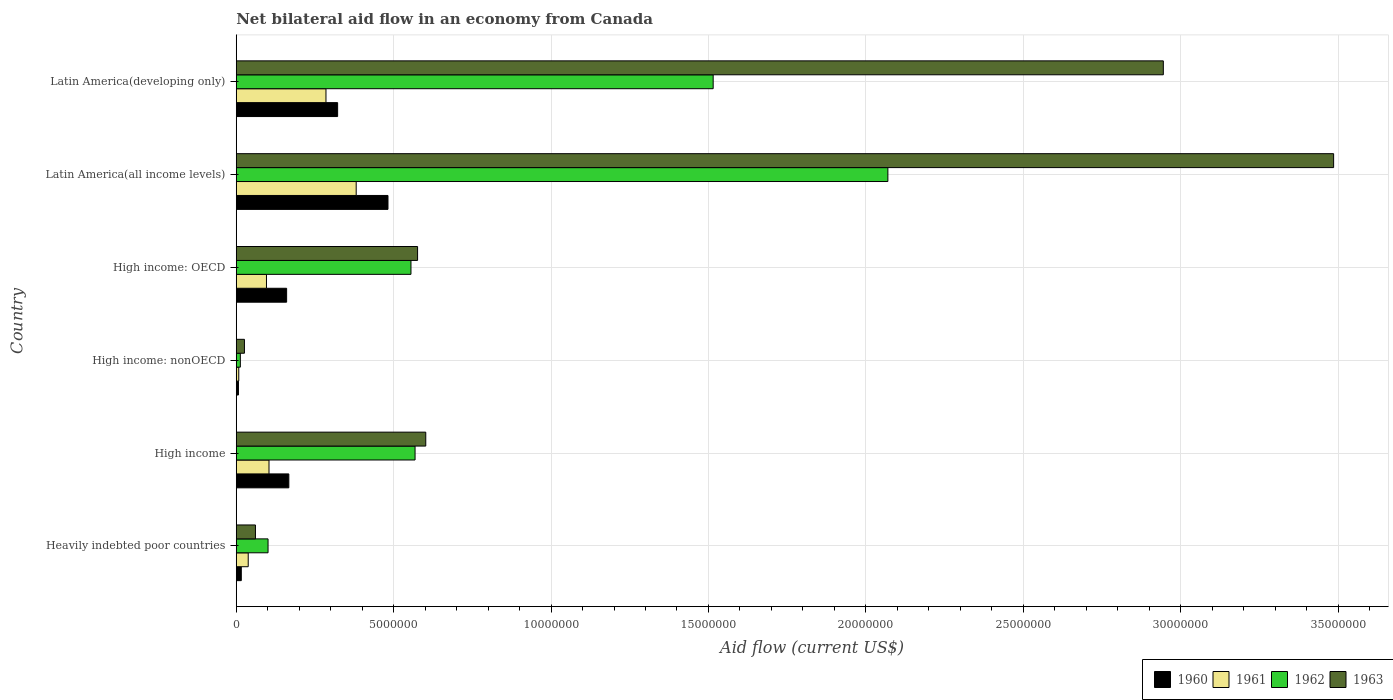How many different coloured bars are there?
Provide a short and direct response. 4. How many groups of bars are there?
Offer a very short reply. 6. Are the number of bars per tick equal to the number of legend labels?
Keep it short and to the point. Yes. How many bars are there on the 6th tick from the top?
Offer a terse response. 4. What is the label of the 4th group of bars from the top?
Provide a short and direct response. High income: nonOECD. Across all countries, what is the maximum net bilateral aid flow in 1961?
Provide a short and direct response. 3.81e+06. In which country was the net bilateral aid flow in 1960 maximum?
Make the answer very short. Latin America(all income levels). In which country was the net bilateral aid flow in 1960 minimum?
Keep it short and to the point. High income: nonOECD. What is the total net bilateral aid flow in 1960 in the graph?
Provide a short and direct response. 1.15e+07. What is the difference between the net bilateral aid flow in 1961 in High income: nonOECD and that in Latin America(all income levels)?
Provide a short and direct response. -3.73e+06. What is the difference between the net bilateral aid flow in 1960 in Latin America(all income levels) and the net bilateral aid flow in 1963 in Latin America(developing only)?
Give a very brief answer. -2.46e+07. What is the average net bilateral aid flow in 1963 per country?
Your response must be concise. 1.28e+07. What is the difference between the net bilateral aid flow in 1961 and net bilateral aid flow in 1962 in Heavily indebted poor countries?
Make the answer very short. -6.30e+05. What is the ratio of the net bilateral aid flow in 1963 in High income to that in Latin America(all income levels)?
Give a very brief answer. 0.17. What is the difference between the highest and the second highest net bilateral aid flow in 1961?
Your response must be concise. 9.60e+05. What is the difference between the highest and the lowest net bilateral aid flow in 1961?
Your answer should be very brief. 3.73e+06. In how many countries, is the net bilateral aid flow in 1960 greater than the average net bilateral aid flow in 1960 taken over all countries?
Your answer should be compact. 2. Is it the case that in every country, the sum of the net bilateral aid flow in 1960 and net bilateral aid flow in 1963 is greater than the net bilateral aid flow in 1962?
Ensure brevity in your answer.  No. How many bars are there?
Offer a very short reply. 24. Are all the bars in the graph horizontal?
Give a very brief answer. Yes. What is the difference between two consecutive major ticks on the X-axis?
Give a very brief answer. 5.00e+06. Does the graph contain any zero values?
Your response must be concise. No. Where does the legend appear in the graph?
Your response must be concise. Bottom right. How many legend labels are there?
Offer a very short reply. 4. How are the legend labels stacked?
Your response must be concise. Horizontal. What is the title of the graph?
Give a very brief answer. Net bilateral aid flow in an economy from Canada. What is the label or title of the X-axis?
Provide a short and direct response. Aid flow (current US$). What is the label or title of the Y-axis?
Your response must be concise. Country. What is the Aid flow (current US$) of 1961 in Heavily indebted poor countries?
Provide a succinct answer. 3.80e+05. What is the Aid flow (current US$) in 1962 in Heavily indebted poor countries?
Provide a short and direct response. 1.01e+06. What is the Aid flow (current US$) of 1960 in High income?
Offer a terse response. 1.67e+06. What is the Aid flow (current US$) of 1961 in High income?
Provide a short and direct response. 1.04e+06. What is the Aid flow (current US$) in 1962 in High income?
Offer a terse response. 5.68e+06. What is the Aid flow (current US$) in 1963 in High income?
Offer a terse response. 6.02e+06. What is the Aid flow (current US$) of 1960 in High income: OECD?
Make the answer very short. 1.60e+06. What is the Aid flow (current US$) in 1961 in High income: OECD?
Keep it short and to the point. 9.60e+05. What is the Aid flow (current US$) in 1962 in High income: OECD?
Your answer should be very brief. 5.55e+06. What is the Aid flow (current US$) of 1963 in High income: OECD?
Ensure brevity in your answer.  5.76e+06. What is the Aid flow (current US$) in 1960 in Latin America(all income levels)?
Give a very brief answer. 4.82e+06. What is the Aid flow (current US$) of 1961 in Latin America(all income levels)?
Keep it short and to the point. 3.81e+06. What is the Aid flow (current US$) in 1962 in Latin America(all income levels)?
Give a very brief answer. 2.07e+07. What is the Aid flow (current US$) of 1963 in Latin America(all income levels)?
Your response must be concise. 3.49e+07. What is the Aid flow (current US$) in 1960 in Latin America(developing only)?
Ensure brevity in your answer.  3.22e+06. What is the Aid flow (current US$) of 1961 in Latin America(developing only)?
Your answer should be compact. 2.85e+06. What is the Aid flow (current US$) in 1962 in Latin America(developing only)?
Offer a terse response. 1.52e+07. What is the Aid flow (current US$) in 1963 in Latin America(developing only)?
Keep it short and to the point. 2.94e+07. Across all countries, what is the maximum Aid flow (current US$) of 1960?
Make the answer very short. 4.82e+06. Across all countries, what is the maximum Aid flow (current US$) of 1961?
Your answer should be compact. 3.81e+06. Across all countries, what is the maximum Aid flow (current US$) of 1962?
Provide a short and direct response. 2.07e+07. Across all countries, what is the maximum Aid flow (current US$) of 1963?
Make the answer very short. 3.49e+07. Across all countries, what is the minimum Aid flow (current US$) in 1960?
Ensure brevity in your answer.  7.00e+04. Across all countries, what is the minimum Aid flow (current US$) of 1961?
Give a very brief answer. 8.00e+04. Across all countries, what is the minimum Aid flow (current US$) of 1962?
Your answer should be compact. 1.30e+05. Across all countries, what is the minimum Aid flow (current US$) of 1963?
Make the answer very short. 2.60e+05. What is the total Aid flow (current US$) of 1960 in the graph?
Keep it short and to the point. 1.15e+07. What is the total Aid flow (current US$) in 1961 in the graph?
Provide a succinct answer. 9.12e+06. What is the total Aid flow (current US$) of 1962 in the graph?
Offer a terse response. 4.82e+07. What is the total Aid flow (current US$) of 1963 in the graph?
Make the answer very short. 7.70e+07. What is the difference between the Aid flow (current US$) in 1960 in Heavily indebted poor countries and that in High income?
Give a very brief answer. -1.51e+06. What is the difference between the Aid flow (current US$) of 1961 in Heavily indebted poor countries and that in High income?
Your answer should be very brief. -6.60e+05. What is the difference between the Aid flow (current US$) of 1962 in Heavily indebted poor countries and that in High income?
Make the answer very short. -4.67e+06. What is the difference between the Aid flow (current US$) of 1963 in Heavily indebted poor countries and that in High income?
Offer a terse response. -5.41e+06. What is the difference between the Aid flow (current US$) of 1961 in Heavily indebted poor countries and that in High income: nonOECD?
Offer a very short reply. 3.00e+05. What is the difference between the Aid flow (current US$) of 1962 in Heavily indebted poor countries and that in High income: nonOECD?
Give a very brief answer. 8.80e+05. What is the difference between the Aid flow (current US$) in 1963 in Heavily indebted poor countries and that in High income: nonOECD?
Offer a very short reply. 3.50e+05. What is the difference between the Aid flow (current US$) in 1960 in Heavily indebted poor countries and that in High income: OECD?
Provide a short and direct response. -1.44e+06. What is the difference between the Aid flow (current US$) of 1961 in Heavily indebted poor countries and that in High income: OECD?
Ensure brevity in your answer.  -5.80e+05. What is the difference between the Aid flow (current US$) of 1962 in Heavily indebted poor countries and that in High income: OECD?
Ensure brevity in your answer.  -4.54e+06. What is the difference between the Aid flow (current US$) in 1963 in Heavily indebted poor countries and that in High income: OECD?
Provide a succinct answer. -5.15e+06. What is the difference between the Aid flow (current US$) in 1960 in Heavily indebted poor countries and that in Latin America(all income levels)?
Your answer should be compact. -4.66e+06. What is the difference between the Aid flow (current US$) of 1961 in Heavily indebted poor countries and that in Latin America(all income levels)?
Make the answer very short. -3.43e+06. What is the difference between the Aid flow (current US$) of 1962 in Heavily indebted poor countries and that in Latin America(all income levels)?
Offer a terse response. -1.97e+07. What is the difference between the Aid flow (current US$) in 1963 in Heavily indebted poor countries and that in Latin America(all income levels)?
Give a very brief answer. -3.42e+07. What is the difference between the Aid flow (current US$) in 1960 in Heavily indebted poor countries and that in Latin America(developing only)?
Keep it short and to the point. -3.06e+06. What is the difference between the Aid flow (current US$) of 1961 in Heavily indebted poor countries and that in Latin America(developing only)?
Offer a terse response. -2.47e+06. What is the difference between the Aid flow (current US$) in 1962 in Heavily indebted poor countries and that in Latin America(developing only)?
Offer a very short reply. -1.41e+07. What is the difference between the Aid flow (current US$) in 1963 in Heavily indebted poor countries and that in Latin America(developing only)?
Ensure brevity in your answer.  -2.88e+07. What is the difference between the Aid flow (current US$) in 1960 in High income and that in High income: nonOECD?
Keep it short and to the point. 1.60e+06. What is the difference between the Aid flow (current US$) of 1961 in High income and that in High income: nonOECD?
Provide a succinct answer. 9.60e+05. What is the difference between the Aid flow (current US$) of 1962 in High income and that in High income: nonOECD?
Offer a terse response. 5.55e+06. What is the difference between the Aid flow (current US$) of 1963 in High income and that in High income: nonOECD?
Offer a terse response. 5.76e+06. What is the difference between the Aid flow (current US$) of 1961 in High income and that in High income: OECD?
Keep it short and to the point. 8.00e+04. What is the difference between the Aid flow (current US$) of 1963 in High income and that in High income: OECD?
Your answer should be very brief. 2.60e+05. What is the difference between the Aid flow (current US$) of 1960 in High income and that in Latin America(all income levels)?
Offer a very short reply. -3.15e+06. What is the difference between the Aid flow (current US$) in 1961 in High income and that in Latin America(all income levels)?
Offer a very short reply. -2.77e+06. What is the difference between the Aid flow (current US$) in 1962 in High income and that in Latin America(all income levels)?
Provide a short and direct response. -1.50e+07. What is the difference between the Aid flow (current US$) in 1963 in High income and that in Latin America(all income levels)?
Make the answer very short. -2.88e+07. What is the difference between the Aid flow (current US$) of 1960 in High income and that in Latin America(developing only)?
Your answer should be very brief. -1.55e+06. What is the difference between the Aid flow (current US$) of 1961 in High income and that in Latin America(developing only)?
Keep it short and to the point. -1.81e+06. What is the difference between the Aid flow (current US$) in 1962 in High income and that in Latin America(developing only)?
Your answer should be very brief. -9.47e+06. What is the difference between the Aid flow (current US$) of 1963 in High income and that in Latin America(developing only)?
Ensure brevity in your answer.  -2.34e+07. What is the difference between the Aid flow (current US$) of 1960 in High income: nonOECD and that in High income: OECD?
Offer a very short reply. -1.53e+06. What is the difference between the Aid flow (current US$) in 1961 in High income: nonOECD and that in High income: OECD?
Ensure brevity in your answer.  -8.80e+05. What is the difference between the Aid flow (current US$) in 1962 in High income: nonOECD and that in High income: OECD?
Keep it short and to the point. -5.42e+06. What is the difference between the Aid flow (current US$) of 1963 in High income: nonOECD and that in High income: OECD?
Ensure brevity in your answer.  -5.50e+06. What is the difference between the Aid flow (current US$) in 1960 in High income: nonOECD and that in Latin America(all income levels)?
Keep it short and to the point. -4.75e+06. What is the difference between the Aid flow (current US$) in 1961 in High income: nonOECD and that in Latin America(all income levels)?
Ensure brevity in your answer.  -3.73e+06. What is the difference between the Aid flow (current US$) in 1962 in High income: nonOECD and that in Latin America(all income levels)?
Keep it short and to the point. -2.06e+07. What is the difference between the Aid flow (current US$) of 1963 in High income: nonOECD and that in Latin America(all income levels)?
Keep it short and to the point. -3.46e+07. What is the difference between the Aid flow (current US$) in 1960 in High income: nonOECD and that in Latin America(developing only)?
Ensure brevity in your answer.  -3.15e+06. What is the difference between the Aid flow (current US$) of 1961 in High income: nonOECD and that in Latin America(developing only)?
Make the answer very short. -2.77e+06. What is the difference between the Aid flow (current US$) of 1962 in High income: nonOECD and that in Latin America(developing only)?
Your answer should be compact. -1.50e+07. What is the difference between the Aid flow (current US$) in 1963 in High income: nonOECD and that in Latin America(developing only)?
Provide a short and direct response. -2.92e+07. What is the difference between the Aid flow (current US$) of 1960 in High income: OECD and that in Latin America(all income levels)?
Your answer should be very brief. -3.22e+06. What is the difference between the Aid flow (current US$) of 1961 in High income: OECD and that in Latin America(all income levels)?
Offer a very short reply. -2.85e+06. What is the difference between the Aid flow (current US$) in 1962 in High income: OECD and that in Latin America(all income levels)?
Your answer should be very brief. -1.52e+07. What is the difference between the Aid flow (current US$) of 1963 in High income: OECD and that in Latin America(all income levels)?
Give a very brief answer. -2.91e+07. What is the difference between the Aid flow (current US$) in 1960 in High income: OECD and that in Latin America(developing only)?
Offer a very short reply. -1.62e+06. What is the difference between the Aid flow (current US$) of 1961 in High income: OECD and that in Latin America(developing only)?
Provide a short and direct response. -1.89e+06. What is the difference between the Aid flow (current US$) of 1962 in High income: OECD and that in Latin America(developing only)?
Your response must be concise. -9.60e+06. What is the difference between the Aid flow (current US$) in 1963 in High income: OECD and that in Latin America(developing only)?
Offer a very short reply. -2.37e+07. What is the difference between the Aid flow (current US$) in 1960 in Latin America(all income levels) and that in Latin America(developing only)?
Offer a terse response. 1.60e+06. What is the difference between the Aid flow (current US$) in 1961 in Latin America(all income levels) and that in Latin America(developing only)?
Provide a succinct answer. 9.60e+05. What is the difference between the Aid flow (current US$) in 1962 in Latin America(all income levels) and that in Latin America(developing only)?
Ensure brevity in your answer.  5.55e+06. What is the difference between the Aid flow (current US$) in 1963 in Latin America(all income levels) and that in Latin America(developing only)?
Your answer should be very brief. 5.41e+06. What is the difference between the Aid flow (current US$) in 1960 in Heavily indebted poor countries and the Aid flow (current US$) in 1961 in High income?
Make the answer very short. -8.80e+05. What is the difference between the Aid flow (current US$) in 1960 in Heavily indebted poor countries and the Aid flow (current US$) in 1962 in High income?
Keep it short and to the point. -5.52e+06. What is the difference between the Aid flow (current US$) of 1960 in Heavily indebted poor countries and the Aid flow (current US$) of 1963 in High income?
Make the answer very short. -5.86e+06. What is the difference between the Aid flow (current US$) of 1961 in Heavily indebted poor countries and the Aid flow (current US$) of 1962 in High income?
Ensure brevity in your answer.  -5.30e+06. What is the difference between the Aid flow (current US$) of 1961 in Heavily indebted poor countries and the Aid flow (current US$) of 1963 in High income?
Your answer should be very brief. -5.64e+06. What is the difference between the Aid flow (current US$) of 1962 in Heavily indebted poor countries and the Aid flow (current US$) of 1963 in High income?
Give a very brief answer. -5.01e+06. What is the difference between the Aid flow (current US$) in 1960 in Heavily indebted poor countries and the Aid flow (current US$) in 1961 in High income: nonOECD?
Offer a terse response. 8.00e+04. What is the difference between the Aid flow (current US$) in 1960 in Heavily indebted poor countries and the Aid flow (current US$) in 1962 in High income: nonOECD?
Provide a succinct answer. 3.00e+04. What is the difference between the Aid flow (current US$) in 1961 in Heavily indebted poor countries and the Aid flow (current US$) in 1962 in High income: nonOECD?
Your response must be concise. 2.50e+05. What is the difference between the Aid flow (current US$) in 1962 in Heavily indebted poor countries and the Aid flow (current US$) in 1963 in High income: nonOECD?
Your response must be concise. 7.50e+05. What is the difference between the Aid flow (current US$) in 1960 in Heavily indebted poor countries and the Aid flow (current US$) in 1961 in High income: OECD?
Your answer should be very brief. -8.00e+05. What is the difference between the Aid flow (current US$) of 1960 in Heavily indebted poor countries and the Aid flow (current US$) of 1962 in High income: OECD?
Provide a short and direct response. -5.39e+06. What is the difference between the Aid flow (current US$) in 1960 in Heavily indebted poor countries and the Aid flow (current US$) in 1963 in High income: OECD?
Provide a short and direct response. -5.60e+06. What is the difference between the Aid flow (current US$) of 1961 in Heavily indebted poor countries and the Aid flow (current US$) of 1962 in High income: OECD?
Offer a terse response. -5.17e+06. What is the difference between the Aid flow (current US$) of 1961 in Heavily indebted poor countries and the Aid flow (current US$) of 1963 in High income: OECD?
Your answer should be very brief. -5.38e+06. What is the difference between the Aid flow (current US$) in 1962 in Heavily indebted poor countries and the Aid flow (current US$) in 1963 in High income: OECD?
Provide a succinct answer. -4.75e+06. What is the difference between the Aid flow (current US$) of 1960 in Heavily indebted poor countries and the Aid flow (current US$) of 1961 in Latin America(all income levels)?
Your answer should be compact. -3.65e+06. What is the difference between the Aid flow (current US$) of 1960 in Heavily indebted poor countries and the Aid flow (current US$) of 1962 in Latin America(all income levels)?
Keep it short and to the point. -2.05e+07. What is the difference between the Aid flow (current US$) of 1960 in Heavily indebted poor countries and the Aid flow (current US$) of 1963 in Latin America(all income levels)?
Provide a short and direct response. -3.47e+07. What is the difference between the Aid flow (current US$) in 1961 in Heavily indebted poor countries and the Aid flow (current US$) in 1962 in Latin America(all income levels)?
Make the answer very short. -2.03e+07. What is the difference between the Aid flow (current US$) in 1961 in Heavily indebted poor countries and the Aid flow (current US$) in 1963 in Latin America(all income levels)?
Provide a short and direct response. -3.45e+07. What is the difference between the Aid flow (current US$) in 1962 in Heavily indebted poor countries and the Aid flow (current US$) in 1963 in Latin America(all income levels)?
Your answer should be very brief. -3.38e+07. What is the difference between the Aid flow (current US$) in 1960 in Heavily indebted poor countries and the Aid flow (current US$) in 1961 in Latin America(developing only)?
Offer a very short reply. -2.69e+06. What is the difference between the Aid flow (current US$) of 1960 in Heavily indebted poor countries and the Aid flow (current US$) of 1962 in Latin America(developing only)?
Offer a very short reply. -1.50e+07. What is the difference between the Aid flow (current US$) of 1960 in Heavily indebted poor countries and the Aid flow (current US$) of 1963 in Latin America(developing only)?
Ensure brevity in your answer.  -2.93e+07. What is the difference between the Aid flow (current US$) of 1961 in Heavily indebted poor countries and the Aid flow (current US$) of 1962 in Latin America(developing only)?
Your answer should be compact. -1.48e+07. What is the difference between the Aid flow (current US$) in 1961 in Heavily indebted poor countries and the Aid flow (current US$) in 1963 in Latin America(developing only)?
Your response must be concise. -2.91e+07. What is the difference between the Aid flow (current US$) in 1962 in Heavily indebted poor countries and the Aid flow (current US$) in 1963 in Latin America(developing only)?
Ensure brevity in your answer.  -2.84e+07. What is the difference between the Aid flow (current US$) in 1960 in High income and the Aid flow (current US$) in 1961 in High income: nonOECD?
Offer a very short reply. 1.59e+06. What is the difference between the Aid flow (current US$) in 1960 in High income and the Aid flow (current US$) in 1962 in High income: nonOECD?
Your answer should be very brief. 1.54e+06. What is the difference between the Aid flow (current US$) of 1960 in High income and the Aid flow (current US$) of 1963 in High income: nonOECD?
Offer a very short reply. 1.41e+06. What is the difference between the Aid flow (current US$) in 1961 in High income and the Aid flow (current US$) in 1962 in High income: nonOECD?
Your response must be concise. 9.10e+05. What is the difference between the Aid flow (current US$) of 1961 in High income and the Aid flow (current US$) of 1963 in High income: nonOECD?
Ensure brevity in your answer.  7.80e+05. What is the difference between the Aid flow (current US$) of 1962 in High income and the Aid flow (current US$) of 1963 in High income: nonOECD?
Provide a succinct answer. 5.42e+06. What is the difference between the Aid flow (current US$) of 1960 in High income and the Aid flow (current US$) of 1961 in High income: OECD?
Offer a very short reply. 7.10e+05. What is the difference between the Aid flow (current US$) in 1960 in High income and the Aid flow (current US$) in 1962 in High income: OECD?
Make the answer very short. -3.88e+06. What is the difference between the Aid flow (current US$) in 1960 in High income and the Aid flow (current US$) in 1963 in High income: OECD?
Your answer should be very brief. -4.09e+06. What is the difference between the Aid flow (current US$) in 1961 in High income and the Aid flow (current US$) in 1962 in High income: OECD?
Give a very brief answer. -4.51e+06. What is the difference between the Aid flow (current US$) of 1961 in High income and the Aid flow (current US$) of 1963 in High income: OECD?
Provide a succinct answer. -4.72e+06. What is the difference between the Aid flow (current US$) of 1962 in High income and the Aid flow (current US$) of 1963 in High income: OECD?
Offer a very short reply. -8.00e+04. What is the difference between the Aid flow (current US$) of 1960 in High income and the Aid flow (current US$) of 1961 in Latin America(all income levels)?
Your answer should be very brief. -2.14e+06. What is the difference between the Aid flow (current US$) in 1960 in High income and the Aid flow (current US$) in 1962 in Latin America(all income levels)?
Offer a very short reply. -1.90e+07. What is the difference between the Aid flow (current US$) in 1960 in High income and the Aid flow (current US$) in 1963 in Latin America(all income levels)?
Keep it short and to the point. -3.32e+07. What is the difference between the Aid flow (current US$) in 1961 in High income and the Aid flow (current US$) in 1962 in Latin America(all income levels)?
Make the answer very short. -1.97e+07. What is the difference between the Aid flow (current US$) of 1961 in High income and the Aid flow (current US$) of 1963 in Latin America(all income levels)?
Offer a very short reply. -3.38e+07. What is the difference between the Aid flow (current US$) of 1962 in High income and the Aid flow (current US$) of 1963 in Latin America(all income levels)?
Offer a very short reply. -2.92e+07. What is the difference between the Aid flow (current US$) of 1960 in High income and the Aid flow (current US$) of 1961 in Latin America(developing only)?
Offer a terse response. -1.18e+06. What is the difference between the Aid flow (current US$) in 1960 in High income and the Aid flow (current US$) in 1962 in Latin America(developing only)?
Provide a short and direct response. -1.35e+07. What is the difference between the Aid flow (current US$) of 1960 in High income and the Aid flow (current US$) of 1963 in Latin America(developing only)?
Provide a succinct answer. -2.78e+07. What is the difference between the Aid flow (current US$) of 1961 in High income and the Aid flow (current US$) of 1962 in Latin America(developing only)?
Keep it short and to the point. -1.41e+07. What is the difference between the Aid flow (current US$) of 1961 in High income and the Aid flow (current US$) of 1963 in Latin America(developing only)?
Ensure brevity in your answer.  -2.84e+07. What is the difference between the Aid flow (current US$) in 1962 in High income and the Aid flow (current US$) in 1963 in Latin America(developing only)?
Offer a terse response. -2.38e+07. What is the difference between the Aid flow (current US$) of 1960 in High income: nonOECD and the Aid flow (current US$) of 1961 in High income: OECD?
Keep it short and to the point. -8.90e+05. What is the difference between the Aid flow (current US$) of 1960 in High income: nonOECD and the Aid flow (current US$) of 1962 in High income: OECD?
Offer a very short reply. -5.48e+06. What is the difference between the Aid flow (current US$) in 1960 in High income: nonOECD and the Aid flow (current US$) in 1963 in High income: OECD?
Offer a very short reply. -5.69e+06. What is the difference between the Aid flow (current US$) of 1961 in High income: nonOECD and the Aid flow (current US$) of 1962 in High income: OECD?
Ensure brevity in your answer.  -5.47e+06. What is the difference between the Aid flow (current US$) of 1961 in High income: nonOECD and the Aid flow (current US$) of 1963 in High income: OECD?
Offer a very short reply. -5.68e+06. What is the difference between the Aid flow (current US$) in 1962 in High income: nonOECD and the Aid flow (current US$) in 1963 in High income: OECD?
Your answer should be very brief. -5.63e+06. What is the difference between the Aid flow (current US$) of 1960 in High income: nonOECD and the Aid flow (current US$) of 1961 in Latin America(all income levels)?
Offer a terse response. -3.74e+06. What is the difference between the Aid flow (current US$) in 1960 in High income: nonOECD and the Aid flow (current US$) in 1962 in Latin America(all income levels)?
Provide a succinct answer. -2.06e+07. What is the difference between the Aid flow (current US$) in 1960 in High income: nonOECD and the Aid flow (current US$) in 1963 in Latin America(all income levels)?
Ensure brevity in your answer.  -3.48e+07. What is the difference between the Aid flow (current US$) in 1961 in High income: nonOECD and the Aid flow (current US$) in 1962 in Latin America(all income levels)?
Offer a very short reply. -2.06e+07. What is the difference between the Aid flow (current US$) in 1961 in High income: nonOECD and the Aid flow (current US$) in 1963 in Latin America(all income levels)?
Provide a short and direct response. -3.48e+07. What is the difference between the Aid flow (current US$) in 1962 in High income: nonOECD and the Aid flow (current US$) in 1963 in Latin America(all income levels)?
Offer a very short reply. -3.47e+07. What is the difference between the Aid flow (current US$) in 1960 in High income: nonOECD and the Aid flow (current US$) in 1961 in Latin America(developing only)?
Offer a terse response. -2.78e+06. What is the difference between the Aid flow (current US$) of 1960 in High income: nonOECD and the Aid flow (current US$) of 1962 in Latin America(developing only)?
Ensure brevity in your answer.  -1.51e+07. What is the difference between the Aid flow (current US$) of 1960 in High income: nonOECD and the Aid flow (current US$) of 1963 in Latin America(developing only)?
Make the answer very short. -2.94e+07. What is the difference between the Aid flow (current US$) in 1961 in High income: nonOECD and the Aid flow (current US$) in 1962 in Latin America(developing only)?
Ensure brevity in your answer.  -1.51e+07. What is the difference between the Aid flow (current US$) in 1961 in High income: nonOECD and the Aid flow (current US$) in 1963 in Latin America(developing only)?
Keep it short and to the point. -2.94e+07. What is the difference between the Aid flow (current US$) of 1962 in High income: nonOECD and the Aid flow (current US$) of 1963 in Latin America(developing only)?
Your response must be concise. -2.93e+07. What is the difference between the Aid flow (current US$) in 1960 in High income: OECD and the Aid flow (current US$) in 1961 in Latin America(all income levels)?
Your response must be concise. -2.21e+06. What is the difference between the Aid flow (current US$) in 1960 in High income: OECD and the Aid flow (current US$) in 1962 in Latin America(all income levels)?
Keep it short and to the point. -1.91e+07. What is the difference between the Aid flow (current US$) in 1960 in High income: OECD and the Aid flow (current US$) in 1963 in Latin America(all income levels)?
Give a very brief answer. -3.33e+07. What is the difference between the Aid flow (current US$) in 1961 in High income: OECD and the Aid flow (current US$) in 1962 in Latin America(all income levels)?
Keep it short and to the point. -1.97e+07. What is the difference between the Aid flow (current US$) in 1961 in High income: OECD and the Aid flow (current US$) in 1963 in Latin America(all income levels)?
Make the answer very short. -3.39e+07. What is the difference between the Aid flow (current US$) of 1962 in High income: OECD and the Aid flow (current US$) of 1963 in Latin America(all income levels)?
Ensure brevity in your answer.  -2.93e+07. What is the difference between the Aid flow (current US$) in 1960 in High income: OECD and the Aid flow (current US$) in 1961 in Latin America(developing only)?
Your response must be concise. -1.25e+06. What is the difference between the Aid flow (current US$) of 1960 in High income: OECD and the Aid flow (current US$) of 1962 in Latin America(developing only)?
Ensure brevity in your answer.  -1.36e+07. What is the difference between the Aid flow (current US$) of 1960 in High income: OECD and the Aid flow (current US$) of 1963 in Latin America(developing only)?
Your answer should be compact. -2.78e+07. What is the difference between the Aid flow (current US$) in 1961 in High income: OECD and the Aid flow (current US$) in 1962 in Latin America(developing only)?
Provide a short and direct response. -1.42e+07. What is the difference between the Aid flow (current US$) in 1961 in High income: OECD and the Aid flow (current US$) in 1963 in Latin America(developing only)?
Offer a terse response. -2.85e+07. What is the difference between the Aid flow (current US$) of 1962 in High income: OECD and the Aid flow (current US$) of 1963 in Latin America(developing only)?
Your response must be concise. -2.39e+07. What is the difference between the Aid flow (current US$) in 1960 in Latin America(all income levels) and the Aid flow (current US$) in 1961 in Latin America(developing only)?
Ensure brevity in your answer.  1.97e+06. What is the difference between the Aid flow (current US$) in 1960 in Latin America(all income levels) and the Aid flow (current US$) in 1962 in Latin America(developing only)?
Ensure brevity in your answer.  -1.03e+07. What is the difference between the Aid flow (current US$) of 1960 in Latin America(all income levels) and the Aid flow (current US$) of 1963 in Latin America(developing only)?
Provide a succinct answer. -2.46e+07. What is the difference between the Aid flow (current US$) of 1961 in Latin America(all income levels) and the Aid flow (current US$) of 1962 in Latin America(developing only)?
Keep it short and to the point. -1.13e+07. What is the difference between the Aid flow (current US$) in 1961 in Latin America(all income levels) and the Aid flow (current US$) in 1963 in Latin America(developing only)?
Provide a succinct answer. -2.56e+07. What is the difference between the Aid flow (current US$) in 1962 in Latin America(all income levels) and the Aid flow (current US$) in 1963 in Latin America(developing only)?
Give a very brief answer. -8.75e+06. What is the average Aid flow (current US$) in 1960 per country?
Provide a succinct answer. 1.92e+06. What is the average Aid flow (current US$) in 1961 per country?
Provide a short and direct response. 1.52e+06. What is the average Aid flow (current US$) in 1962 per country?
Make the answer very short. 8.04e+06. What is the average Aid flow (current US$) of 1963 per country?
Your answer should be very brief. 1.28e+07. What is the difference between the Aid flow (current US$) of 1960 and Aid flow (current US$) of 1961 in Heavily indebted poor countries?
Make the answer very short. -2.20e+05. What is the difference between the Aid flow (current US$) of 1960 and Aid flow (current US$) of 1962 in Heavily indebted poor countries?
Give a very brief answer. -8.50e+05. What is the difference between the Aid flow (current US$) of 1960 and Aid flow (current US$) of 1963 in Heavily indebted poor countries?
Your answer should be very brief. -4.50e+05. What is the difference between the Aid flow (current US$) of 1961 and Aid flow (current US$) of 1962 in Heavily indebted poor countries?
Keep it short and to the point. -6.30e+05. What is the difference between the Aid flow (current US$) of 1961 and Aid flow (current US$) of 1963 in Heavily indebted poor countries?
Your answer should be very brief. -2.30e+05. What is the difference between the Aid flow (current US$) of 1960 and Aid flow (current US$) of 1961 in High income?
Offer a terse response. 6.30e+05. What is the difference between the Aid flow (current US$) of 1960 and Aid flow (current US$) of 1962 in High income?
Your answer should be very brief. -4.01e+06. What is the difference between the Aid flow (current US$) of 1960 and Aid flow (current US$) of 1963 in High income?
Give a very brief answer. -4.35e+06. What is the difference between the Aid flow (current US$) in 1961 and Aid flow (current US$) in 1962 in High income?
Provide a succinct answer. -4.64e+06. What is the difference between the Aid flow (current US$) in 1961 and Aid flow (current US$) in 1963 in High income?
Offer a terse response. -4.98e+06. What is the difference between the Aid flow (current US$) of 1960 and Aid flow (current US$) of 1961 in High income: nonOECD?
Offer a very short reply. -10000. What is the difference between the Aid flow (current US$) of 1960 and Aid flow (current US$) of 1963 in High income: nonOECD?
Provide a short and direct response. -1.90e+05. What is the difference between the Aid flow (current US$) of 1961 and Aid flow (current US$) of 1962 in High income: nonOECD?
Provide a succinct answer. -5.00e+04. What is the difference between the Aid flow (current US$) in 1961 and Aid flow (current US$) in 1963 in High income: nonOECD?
Your answer should be very brief. -1.80e+05. What is the difference between the Aid flow (current US$) of 1960 and Aid flow (current US$) of 1961 in High income: OECD?
Make the answer very short. 6.40e+05. What is the difference between the Aid flow (current US$) of 1960 and Aid flow (current US$) of 1962 in High income: OECD?
Provide a short and direct response. -3.95e+06. What is the difference between the Aid flow (current US$) of 1960 and Aid flow (current US$) of 1963 in High income: OECD?
Offer a very short reply. -4.16e+06. What is the difference between the Aid flow (current US$) of 1961 and Aid flow (current US$) of 1962 in High income: OECD?
Your answer should be very brief. -4.59e+06. What is the difference between the Aid flow (current US$) of 1961 and Aid flow (current US$) of 1963 in High income: OECD?
Give a very brief answer. -4.80e+06. What is the difference between the Aid flow (current US$) of 1960 and Aid flow (current US$) of 1961 in Latin America(all income levels)?
Your response must be concise. 1.01e+06. What is the difference between the Aid flow (current US$) of 1960 and Aid flow (current US$) of 1962 in Latin America(all income levels)?
Provide a succinct answer. -1.59e+07. What is the difference between the Aid flow (current US$) of 1960 and Aid flow (current US$) of 1963 in Latin America(all income levels)?
Give a very brief answer. -3.00e+07. What is the difference between the Aid flow (current US$) in 1961 and Aid flow (current US$) in 1962 in Latin America(all income levels)?
Offer a very short reply. -1.69e+07. What is the difference between the Aid flow (current US$) of 1961 and Aid flow (current US$) of 1963 in Latin America(all income levels)?
Give a very brief answer. -3.10e+07. What is the difference between the Aid flow (current US$) of 1962 and Aid flow (current US$) of 1963 in Latin America(all income levels)?
Ensure brevity in your answer.  -1.42e+07. What is the difference between the Aid flow (current US$) of 1960 and Aid flow (current US$) of 1962 in Latin America(developing only)?
Offer a very short reply. -1.19e+07. What is the difference between the Aid flow (current US$) of 1960 and Aid flow (current US$) of 1963 in Latin America(developing only)?
Your answer should be compact. -2.62e+07. What is the difference between the Aid flow (current US$) in 1961 and Aid flow (current US$) in 1962 in Latin America(developing only)?
Your answer should be compact. -1.23e+07. What is the difference between the Aid flow (current US$) in 1961 and Aid flow (current US$) in 1963 in Latin America(developing only)?
Give a very brief answer. -2.66e+07. What is the difference between the Aid flow (current US$) in 1962 and Aid flow (current US$) in 1963 in Latin America(developing only)?
Your answer should be compact. -1.43e+07. What is the ratio of the Aid flow (current US$) of 1960 in Heavily indebted poor countries to that in High income?
Your answer should be compact. 0.1. What is the ratio of the Aid flow (current US$) in 1961 in Heavily indebted poor countries to that in High income?
Make the answer very short. 0.37. What is the ratio of the Aid flow (current US$) of 1962 in Heavily indebted poor countries to that in High income?
Ensure brevity in your answer.  0.18. What is the ratio of the Aid flow (current US$) in 1963 in Heavily indebted poor countries to that in High income?
Provide a succinct answer. 0.1. What is the ratio of the Aid flow (current US$) in 1960 in Heavily indebted poor countries to that in High income: nonOECD?
Provide a succinct answer. 2.29. What is the ratio of the Aid flow (current US$) of 1961 in Heavily indebted poor countries to that in High income: nonOECD?
Provide a short and direct response. 4.75. What is the ratio of the Aid flow (current US$) of 1962 in Heavily indebted poor countries to that in High income: nonOECD?
Provide a short and direct response. 7.77. What is the ratio of the Aid flow (current US$) in 1963 in Heavily indebted poor countries to that in High income: nonOECD?
Give a very brief answer. 2.35. What is the ratio of the Aid flow (current US$) in 1960 in Heavily indebted poor countries to that in High income: OECD?
Ensure brevity in your answer.  0.1. What is the ratio of the Aid flow (current US$) of 1961 in Heavily indebted poor countries to that in High income: OECD?
Your answer should be very brief. 0.4. What is the ratio of the Aid flow (current US$) of 1962 in Heavily indebted poor countries to that in High income: OECD?
Give a very brief answer. 0.18. What is the ratio of the Aid flow (current US$) in 1963 in Heavily indebted poor countries to that in High income: OECD?
Offer a terse response. 0.11. What is the ratio of the Aid flow (current US$) of 1960 in Heavily indebted poor countries to that in Latin America(all income levels)?
Your answer should be compact. 0.03. What is the ratio of the Aid flow (current US$) of 1961 in Heavily indebted poor countries to that in Latin America(all income levels)?
Your response must be concise. 0.1. What is the ratio of the Aid flow (current US$) in 1962 in Heavily indebted poor countries to that in Latin America(all income levels)?
Offer a very short reply. 0.05. What is the ratio of the Aid flow (current US$) in 1963 in Heavily indebted poor countries to that in Latin America(all income levels)?
Make the answer very short. 0.02. What is the ratio of the Aid flow (current US$) of 1960 in Heavily indebted poor countries to that in Latin America(developing only)?
Keep it short and to the point. 0.05. What is the ratio of the Aid flow (current US$) of 1961 in Heavily indebted poor countries to that in Latin America(developing only)?
Offer a terse response. 0.13. What is the ratio of the Aid flow (current US$) of 1962 in Heavily indebted poor countries to that in Latin America(developing only)?
Offer a very short reply. 0.07. What is the ratio of the Aid flow (current US$) in 1963 in Heavily indebted poor countries to that in Latin America(developing only)?
Your answer should be very brief. 0.02. What is the ratio of the Aid flow (current US$) in 1960 in High income to that in High income: nonOECD?
Give a very brief answer. 23.86. What is the ratio of the Aid flow (current US$) of 1962 in High income to that in High income: nonOECD?
Make the answer very short. 43.69. What is the ratio of the Aid flow (current US$) of 1963 in High income to that in High income: nonOECD?
Your response must be concise. 23.15. What is the ratio of the Aid flow (current US$) of 1960 in High income to that in High income: OECD?
Offer a terse response. 1.04. What is the ratio of the Aid flow (current US$) of 1962 in High income to that in High income: OECD?
Keep it short and to the point. 1.02. What is the ratio of the Aid flow (current US$) of 1963 in High income to that in High income: OECD?
Your response must be concise. 1.05. What is the ratio of the Aid flow (current US$) of 1960 in High income to that in Latin America(all income levels)?
Offer a very short reply. 0.35. What is the ratio of the Aid flow (current US$) in 1961 in High income to that in Latin America(all income levels)?
Provide a short and direct response. 0.27. What is the ratio of the Aid flow (current US$) in 1962 in High income to that in Latin America(all income levels)?
Ensure brevity in your answer.  0.27. What is the ratio of the Aid flow (current US$) of 1963 in High income to that in Latin America(all income levels)?
Make the answer very short. 0.17. What is the ratio of the Aid flow (current US$) of 1960 in High income to that in Latin America(developing only)?
Provide a short and direct response. 0.52. What is the ratio of the Aid flow (current US$) in 1961 in High income to that in Latin America(developing only)?
Make the answer very short. 0.36. What is the ratio of the Aid flow (current US$) of 1962 in High income to that in Latin America(developing only)?
Offer a very short reply. 0.37. What is the ratio of the Aid flow (current US$) of 1963 in High income to that in Latin America(developing only)?
Offer a terse response. 0.2. What is the ratio of the Aid flow (current US$) in 1960 in High income: nonOECD to that in High income: OECD?
Your answer should be very brief. 0.04. What is the ratio of the Aid flow (current US$) in 1961 in High income: nonOECD to that in High income: OECD?
Keep it short and to the point. 0.08. What is the ratio of the Aid flow (current US$) of 1962 in High income: nonOECD to that in High income: OECD?
Your answer should be compact. 0.02. What is the ratio of the Aid flow (current US$) in 1963 in High income: nonOECD to that in High income: OECD?
Give a very brief answer. 0.05. What is the ratio of the Aid flow (current US$) in 1960 in High income: nonOECD to that in Latin America(all income levels)?
Make the answer very short. 0.01. What is the ratio of the Aid flow (current US$) of 1961 in High income: nonOECD to that in Latin America(all income levels)?
Make the answer very short. 0.02. What is the ratio of the Aid flow (current US$) in 1962 in High income: nonOECD to that in Latin America(all income levels)?
Keep it short and to the point. 0.01. What is the ratio of the Aid flow (current US$) of 1963 in High income: nonOECD to that in Latin America(all income levels)?
Your answer should be very brief. 0.01. What is the ratio of the Aid flow (current US$) of 1960 in High income: nonOECD to that in Latin America(developing only)?
Provide a short and direct response. 0.02. What is the ratio of the Aid flow (current US$) in 1961 in High income: nonOECD to that in Latin America(developing only)?
Make the answer very short. 0.03. What is the ratio of the Aid flow (current US$) in 1962 in High income: nonOECD to that in Latin America(developing only)?
Offer a very short reply. 0.01. What is the ratio of the Aid flow (current US$) in 1963 in High income: nonOECD to that in Latin America(developing only)?
Provide a short and direct response. 0.01. What is the ratio of the Aid flow (current US$) of 1960 in High income: OECD to that in Latin America(all income levels)?
Ensure brevity in your answer.  0.33. What is the ratio of the Aid flow (current US$) of 1961 in High income: OECD to that in Latin America(all income levels)?
Your answer should be compact. 0.25. What is the ratio of the Aid flow (current US$) of 1962 in High income: OECD to that in Latin America(all income levels)?
Give a very brief answer. 0.27. What is the ratio of the Aid flow (current US$) in 1963 in High income: OECD to that in Latin America(all income levels)?
Offer a very short reply. 0.17. What is the ratio of the Aid flow (current US$) of 1960 in High income: OECD to that in Latin America(developing only)?
Your response must be concise. 0.5. What is the ratio of the Aid flow (current US$) of 1961 in High income: OECD to that in Latin America(developing only)?
Your response must be concise. 0.34. What is the ratio of the Aid flow (current US$) in 1962 in High income: OECD to that in Latin America(developing only)?
Provide a succinct answer. 0.37. What is the ratio of the Aid flow (current US$) of 1963 in High income: OECD to that in Latin America(developing only)?
Your answer should be compact. 0.2. What is the ratio of the Aid flow (current US$) in 1960 in Latin America(all income levels) to that in Latin America(developing only)?
Ensure brevity in your answer.  1.5. What is the ratio of the Aid flow (current US$) of 1961 in Latin America(all income levels) to that in Latin America(developing only)?
Keep it short and to the point. 1.34. What is the ratio of the Aid flow (current US$) of 1962 in Latin America(all income levels) to that in Latin America(developing only)?
Give a very brief answer. 1.37. What is the ratio of the Aid flow (current US$) in 1963 in Latin America(all income levels) to that in Latin America(developing only)?
Offer a terse response. 1.18. What is the difference between the highest and the second highest Aid flow (current US$) in 1960?
Give a very brief answer. 1.60e+06. What is the difference between the highest and the second highest Aid flow (current US$) in 1961?
Your response must be concise. 9.60e+05. What is the difference between the highest and the second highest Aid flow (current US$) of 1962?
Offer a very short reply. 5.55e+06. What is the difference between the highest and the second highest Aid flow (current US$) in 1963?
Provide a short and direct response. 5.41e+06. What is the difference between the highest and the lowest Aid flow (current US$) of 1960?
Make the answer very short. 4.75e+06. What is the difference between the highest and the lowest Aid flow (current US$) in 1961?
Your answer should be very brief. 3.73e+06. What is the difference between the highest and the lowest Aid flow (current US$) in 1962?
Make the answer very short. 2.06e+07. What is the difference between the highest and the lowest Aid flow (current US$) of 1963?
Provide a succinct answer. 3.46e+07. 